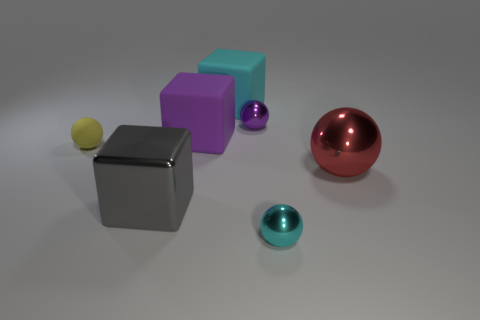There is a gray object that is the same material as the purple sphere; what shape is it?
Provide a succinct answer. Cube. There is a cyan thing that is on the right side of the big rubber thing behind the purple shiny object; how big is it?
Offer a terse response. Small. The cube that is in front of the rubber ball is what color?
Keep it short and to the point. Gray. Is there a purple object that has the same shape as the yellow object?
Your answer should be compact. Yes. Is the number of shiny balls behind the cyan shiny object less than the number of small yellow rubber balls on the right side of the small yellow ball?
Your response must be concise. No. What is the color of the rubber sphere?
Make the answer very short. Yellow. Is there a matte sphere in front of the big metallic object on the left side of the red metallic thing?
Ensure brevity in your answer.  No. What number of blue rubber things are the same size as the cyan metallic thing?
Offer a very short reply. 0. How many tiny purple balls are to the left of the tiny metallic sphere in front of the large metal thing that is on the right side of the cyan metallic ball?
Offer a terse response. 1. What number of spheres are in front of the purple metal sphere and behind the big gray block?
Offer a terse response. 2. 